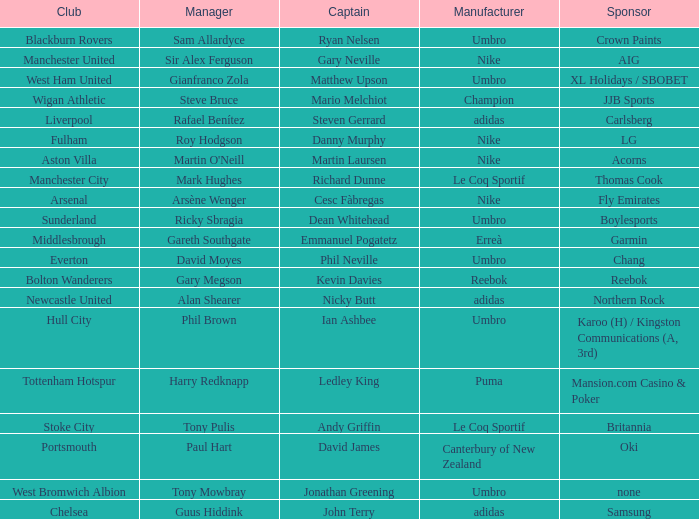Who is Dean Whitehead's manager? Ricky Sbragia. 